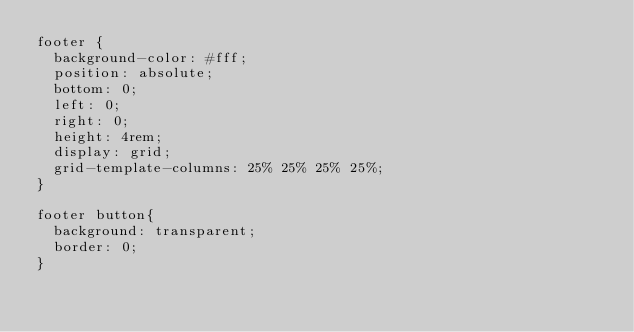<code> <loc_0><loc_0><loc_500><loc_500><_CSS_>footer {
  background-color: #fff;
  position: absolute;
  bottom: 0;
  left: 0;
  right: 0;
  height: 4rem;
  display: grid;
  grid-template-columns: 25% 25% 25% 25%;
}

footer button{
  background: transparent;
  border: 0;
}</code> 